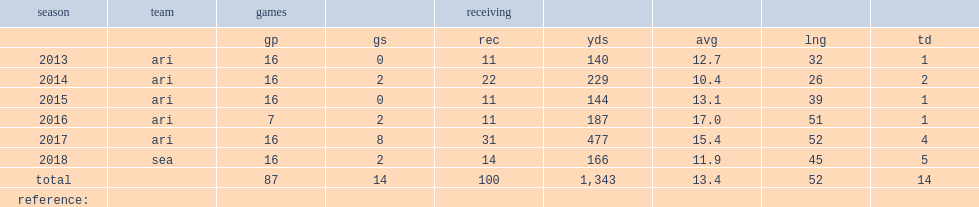How many receptions did brown finish the 2015 nfl season with? 11.0. 